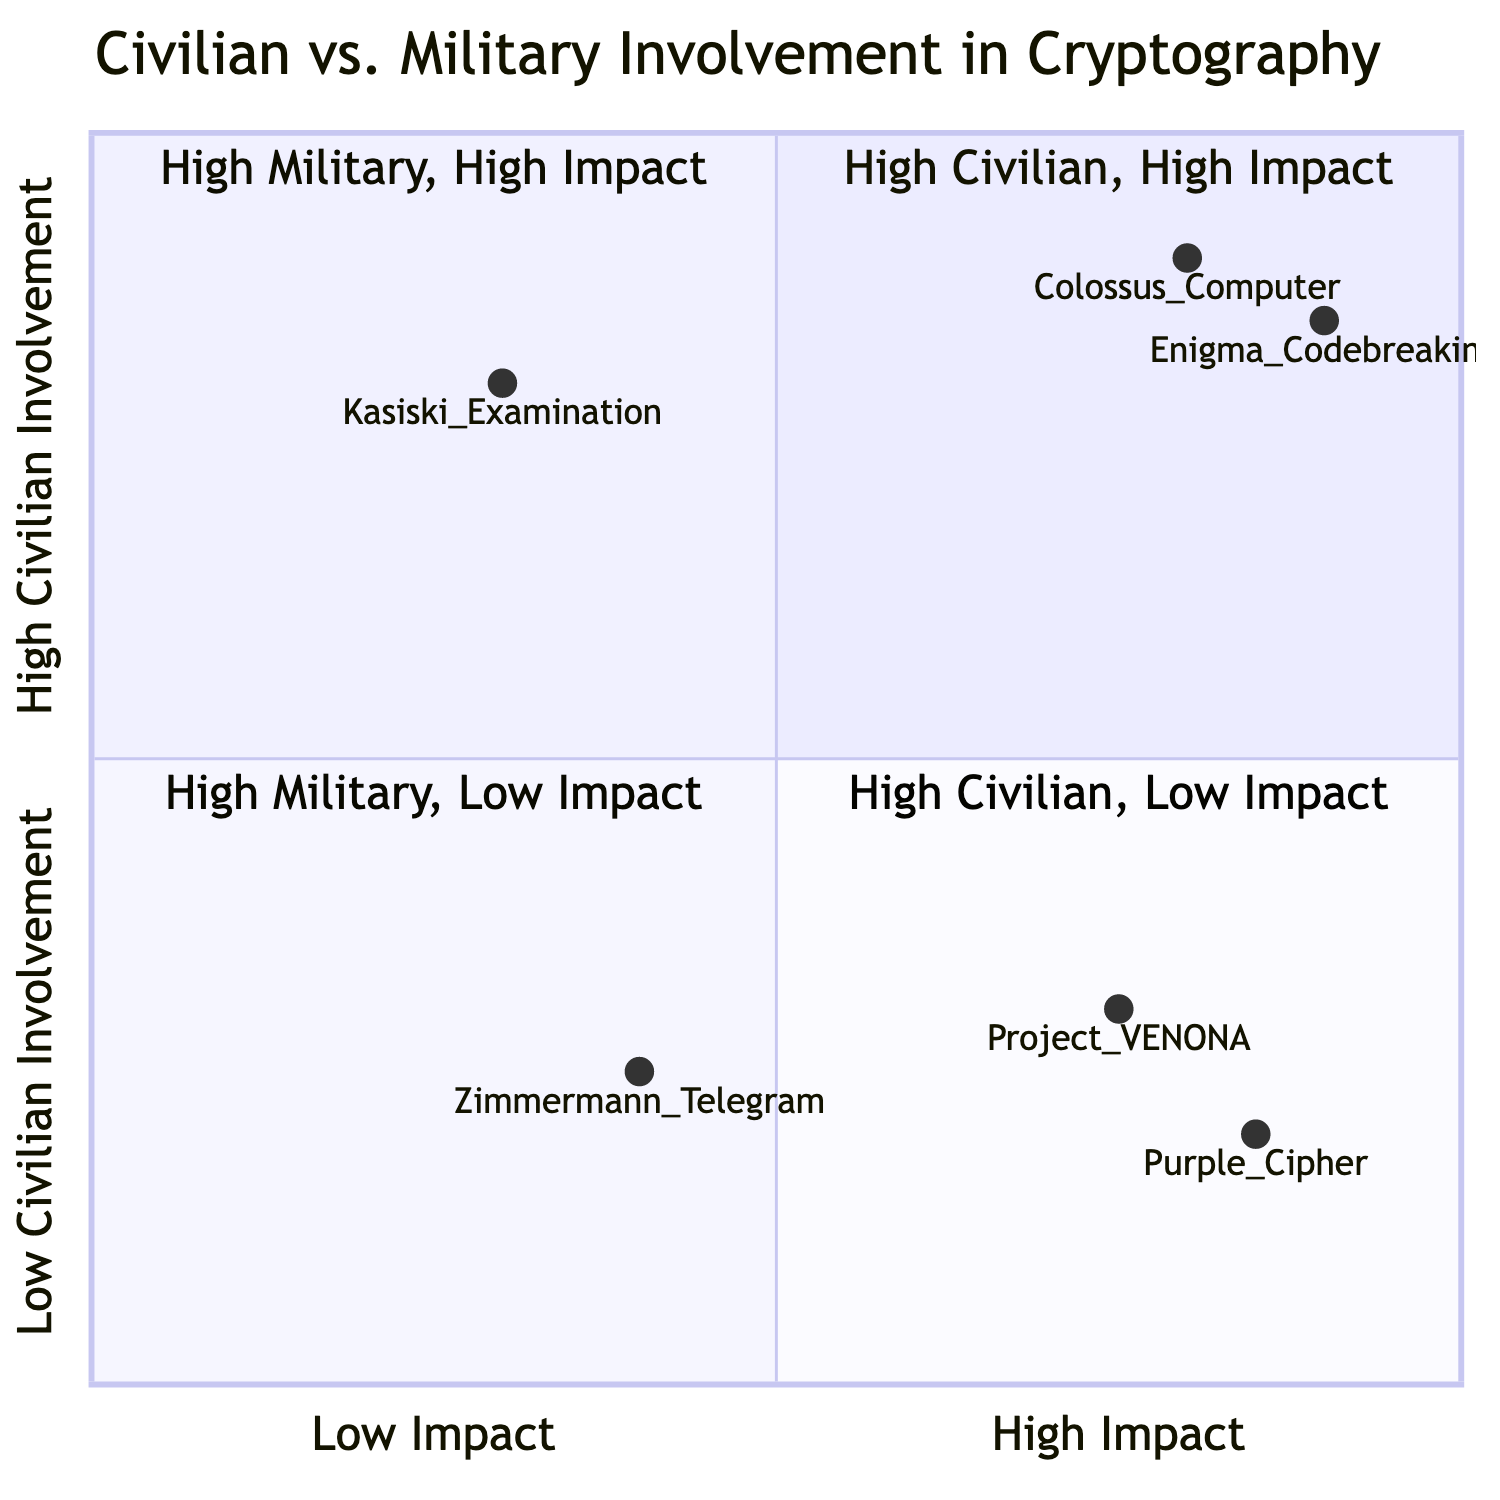What is positioned in the High Civilian Involvement, High Impact quadrant? The High Civilian Involvement, High Impact quadrant contains the Colossus Computer and Enigma Codebreaking.
Answer: Colossus Computer, Enigma Codebreaking How many elements are in the High Military Involvement, Low Impact quadrant? The High Military Involvement, Low Impact quadrant has one element, which is the Zimmermann Telegram.
Answer: 1 Which element has the highest impact on the diagram? The Enigma Codebreaking has the highest impact as it is placed furthest to the right in the High Civilian Involvement, High Impact quadrant.
Answer: Enigma Codebreaking What is the impact level of the Kasiski Examination? The Kasiski Examination is categorized in the High Civilian Involvement, Low Impact quadrant, indicating low impact.
Answer: Low Impact In which quadrant is the Purple Cipher located? The Purple Cipher is located in the High Military Involvement, High Impact quadrant, indicating significant military influence and impact.
Answer: High Military Involvement, High Impact What is the main difference between the Zimmermann Telegram and Project VENONA regarding their impact? The Zimmermann Telegram is categorized as having low impact, while Project VENONA is in the High Military Involvement, High Impact quadrant, denoting higher significance.
Answer: Low Impact vs. High Impact Which element shows a blend of military and civilian involvement yet indicates low impact? The Zimmermann Telegram shows military involvement but indicates low impact in the diagram.
Answer: Zimmermann Telegram What is the underlying similarity between the Colossus Computer and Enigma Codebreaking elements? Both elements illustrate high civilian involvement and high impact in cryptography development during wartime.
Answer: High Civilian Involvement, High Impact 